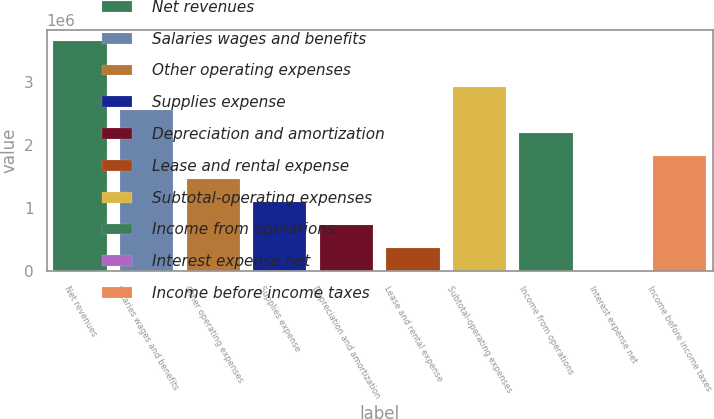Convert chart. <chart><loc_0><loc_0><loc_500><loc_500><bar_chart><fcel>Net revenues<fcel>Salaries wages and benefits<fcel>Other operating expenses<fcel>Supplies expense<fcel>Depreciation and amortization<fcel>Lease and rental expense<fcel>Subtotal-operating expenses<fcel>Income from operations<fcel>Interest expense net<fcel>Income before income taxes<nl><fcel>3.65313e+06<fcel>2.55781e+06<fcel>1.4625e+06<fcel>1.09739e+06<fcel>732289<fcel>367184<fcel>2.92292e+06<fcel>2.19271e+06<fcel>2079<fcel>1.8276e+06<nl></chart> 